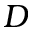<formula> <loc_0><loc_0><loc_500><loc_500>D</formula> 